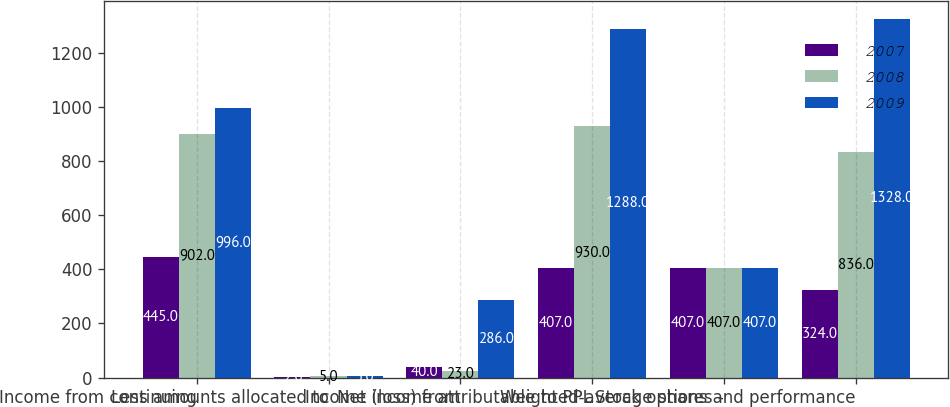<chart> <loc_0><loc_0><loc_500><loc_500><stacked_bar_chart><ecel><fcel>Income from continuing<fcel>Less amounts allocated to<fcel>Income (loss) from<fcel>Net income attributable to PPL<fcel>Weighted-average shares -<fcel>Stock options and performance<nl><fcel>2007<fcel>445<fcel>2<fcel>40<fcel>407<fcel>407<fcel>324<nl><fcel>2008<fcel>902<fcel>5<fcel>23<fcel>930<fcel>407<fcel>836<nl><fcel>2009<fcel>996<fcel>5<fcel>286<fcel>1288<fcel>407<fcel>1328<nl></chart> 